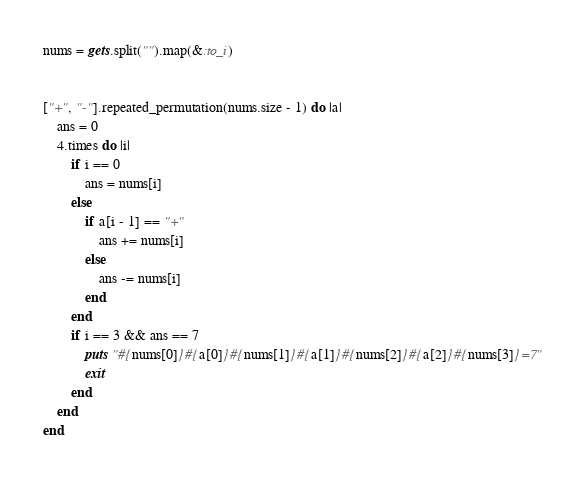Convert code to text. <code><loc_0><loc_0><loc_500><loc_500><_Ruby_>nums = gets.split("").map(&:to_i)


["+", "-"].repeated_permutation(nums.size - 1) do |a|
    ans = 0
    4.times do |i|
        if i == 0
            ans = nums[i]
        else
            if a[i - 1] == "+"
                ans += nums[i]
            else
                ans -= nums[i]
            end
        end
        if i == 3 && ans == 7
            puts "#{nums[0]}#{a[0]}#{nums[1]}#{a[1]}#{nums[2]}#{a[2]}#{nums[3]}=7"
            exit
        end
    end
end</code> 